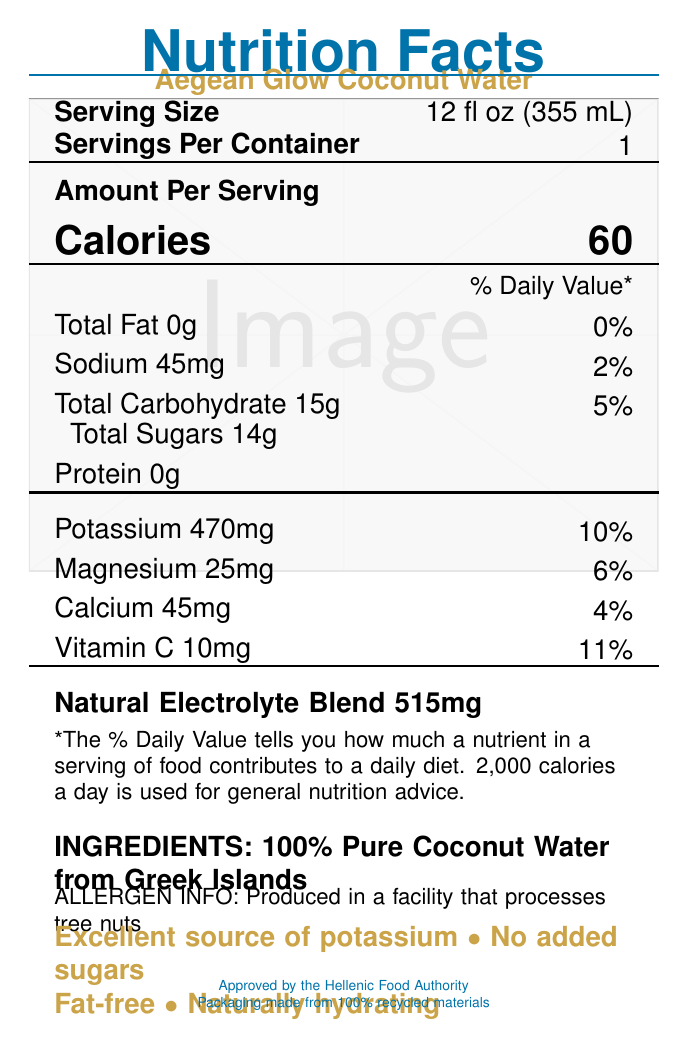what is the serving size for Aegean Glow Coconut Water? The document states the serving size is 12 fl oz (355 mL).
Answer: 12 fl oz (355 mL) how many calories are in one serving of Aegean Glow Coconut Water? The document specifies that one serving has 60 calories.
Answer: 60 calories what is the amount of potassium in a serving, and its Daily Value percentage? The document lists potassium content as 470mg, which is 10% of the Daily Value.
Answer: 470mg, 10% List the electrolytes mentioned in the document and their total amount. The document mentions a Natural Electrolyte Blend with a total amount of 515mg.
Answer: Natural Electrolyte Blend, 515mg does Aegean Glow Coconut Water contain any fat? The document indicates that the Total Fat content is 0g, which is 0% Daily Value.
Answer: No how much sodium is in a single serving? The document lists sodium content as 45mg per serving.
Answer: 45mg what sources are the ingredients of Aegean Glow Coconut Water derived from? The document specifies that the coconut water is "100% Pure Coconut Water from Greek Islands."
Answer: Greek Islands what is the Daily Value percentage of Vitamin C in one serving? The document lists Vitamin C as 10mg, which is 11% of the Daily Value.
Answer: 11% which of the following health claims is made about Aegean Glow Coconut Water? A. Contains added sugars B. Good source of fiber C. Excellent source of potassium D. High in protein The document includes the health claim "Excellent source of potassium."
Answer: C what amount of calcium is in this coconut water, and what is its Daily Value percentage? The document states that one serving contains 45mg of calcium, which corresponds to 4% of the Daily Value.
Answer: 45mg, 4% which of the following statements about the product's packaging is true? A. Made from 100% recycled materials B. Made from non-recyclable materials C. Biodegradable D. Derived from natural sources The document specifies that the packaging is made from 100% recycled materials.
Answer: A is there any mention of allergens in the document? The document includes an allergen info section that states, "Produced in a facility that processes tree nuts."
Answer: Yes summarize the main idea of the document. The document provides detailed nutritional information, ingredient sources, health claims, and packaging information about Aegean Glow Coconut Water, emphasizing its hydrating properties and essential nutrient content.
Answer: Aegean Glow Coconut Water is a hydrating beverage made from 100% pure coconut water from the Greek Islands. It contains essential electrolytes and nutrients such as potassium, magnesium, calcium, and vitamin C, with no added sugars and zero fat. The packaging is eco-friendly, and the product is produced in a facility that handles tree nuts. what is the health benefit mentioned for the product in terms of skin care? The document does not provide specific detailed information about direct skin care benefits but mentions hydration for overall wellness, which could implicitly benefit skin health.
Answer: Not enough information how much magnesium is in one serving, and what percentage of the Daily Value does it represent? The document states that one serving has 25mg of magnesium, which represents 6% of the Daily Value.
Answer: 25mg, 6% does the product have any added sugars? The document includes the health claim "No added sugars," implying that it only contains naturally occurring sugars.
Answer: No what organization approved this product? The document mentions that the product is "Approved by the Hellenic Food Authority."
Answer: The Hellenic Food Authority 